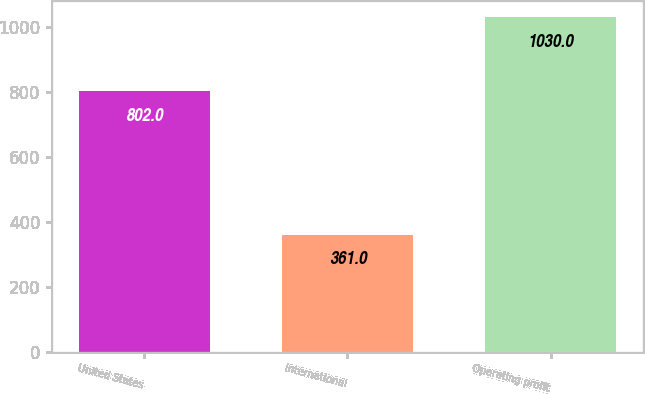<chart> <loc_0><loc_0><loc_500><loc_500><bar_chart><fcel>United States<fcel>International<fcel>Operating profit<nl><fcel>802<fcel>361<fcel>1030<nl></chart> 